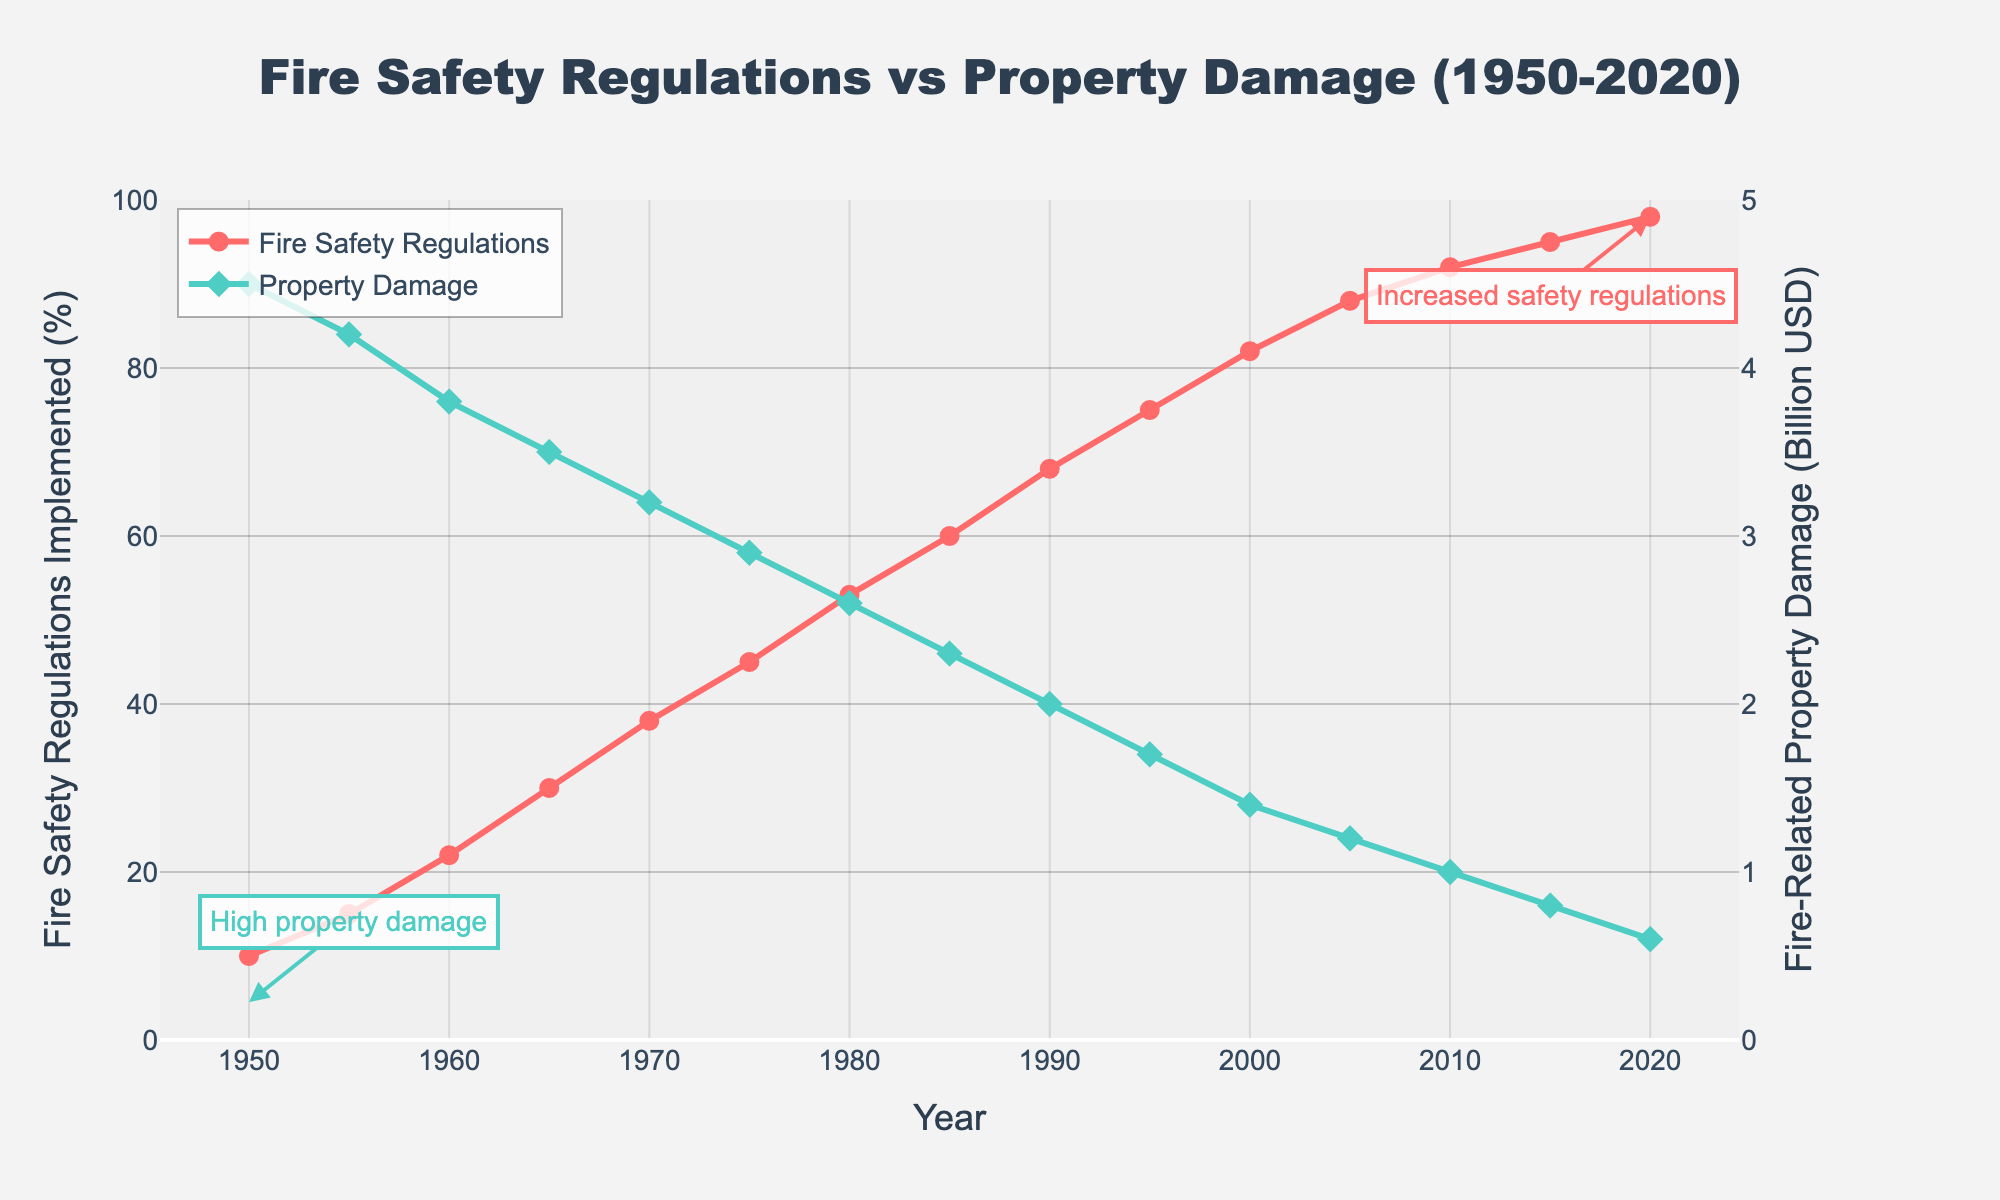What's the trend in the implementation of fire safety regulations between 1950 and 2020? Between 1950 and 2020, the percentage of fire safety regulations implemented shows an increasing trend. Starting from 10% in 1950, it continuously rises and reaches 98% by 2020.
Answer: Increasing trend How did fire-related property damage change from 1950 to 2020? Fire-related property damage decreased from 4.5 billion USD in 1950 to 0.6 billion USD in 2020.
Answer: Decreased What can we infer about the relationship between fire safety regulations implemented and fire-related property damage over time? As the implementation percentage of fire safety regulations increased from 10% to 98%, the fire-related property damage decreased from 4.5 billion USD to 0.6 billion USD. This suggests a negative correlation between the extent of fire safety regulations and the amount of property damage.
Answer: Negative correlation In what year did the fire safety regulations implemented exceed 50%, and what was the value of fire-related property damage at that time? In 1980, the fire safety regulations implemented exceeded 50% (reached 53%) and the fire-related property damage was 2.6 billion USD.
Answer: 1980, 2.6 billion USD Compare the fire-related property damage amounts in 1950 and 2000. By how much did it decrease? Fire-related property damage in 1950 was 4.5 billion USD, and in 2000 it was 1.4 billion USD. The decrease is 4.5 - 1.4 = 3.1 billion USD.
Answer: 3.1 billion USD What is the approximate decade range when the fire-related property damage was consistently below 2 billion USD? Fire-related property damage started being consistently below 2 billion USD around the 1990s (from circa 1995) and continued to stay below 2 billion USD until 2020.
Answer: 1990s What visual attributes indicate the high initial property damage and increased safety regulations by 2020 on the chart? The annotations highlight "High property damage" near the 1950s and "Increased safety regulations" near 2020. The green diamond marks and line signifying property damage start high and lower respectively, while the red circle marks and line for safety regulations show the reverse pattern, starting low and ending high.
Answer: Annotations and markers What's the average percentage of fire safety regulations implemented between 1950 and 2000? To find the average: (10 + 15 + 22 + 30 + 38 + 45 + 53 + 60 + 68 + 75 + 82) / 11 = 44.36%.
Answer: 44.36% By how much did the fire-related property damage reduce from 1985 to 1995? In 1985, fire-related property damage was 2.3 billion USD, and in 1995 it was 1.7 billion USD. The reduction is 2.3 - 1.7 = 0.6 billion USD.
Answer: 0.6 billion USD 